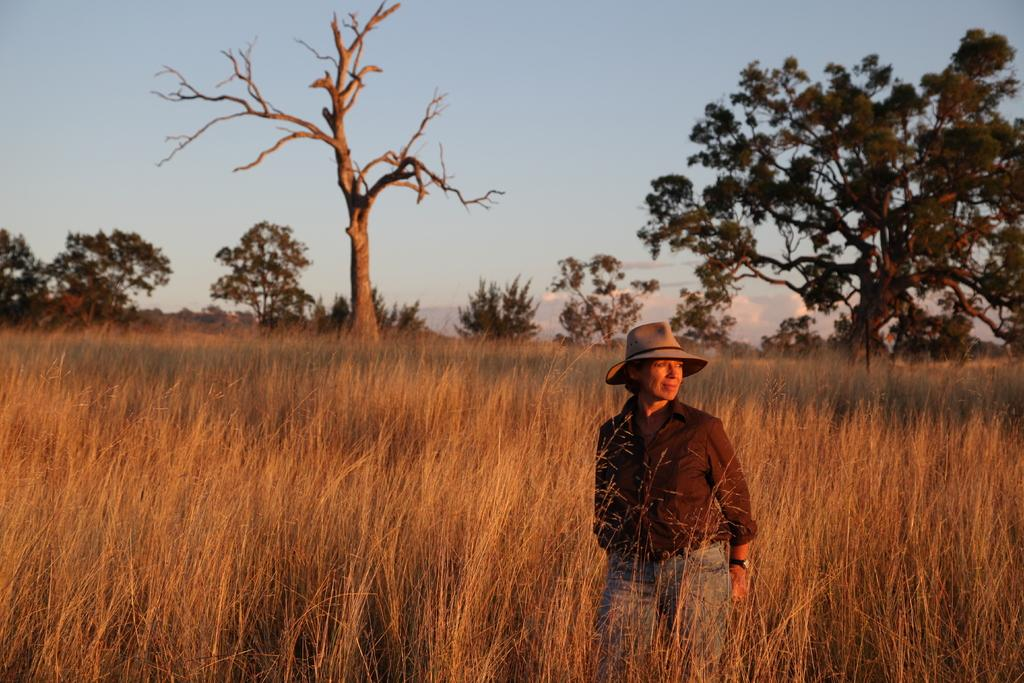What is located in the foreground of the image? There is a field and a woman in the foreground of the image. What can be seen in the middle of the image? There are trees in the middle of the image. What is visible at the top of the image? The sky is visible at the top of the image. Is there a carriage being pulled by a team of horses in the image? No, there is no carriage or horses present in the image. What type of friction can be observed between the woman and the field in the image? There is no friction between the woman and the field in the image, as they are not interacting in a way that would cause friction. 